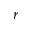<formula> <loc_0><loc_0><loc_500><loc_500>r</formula> 